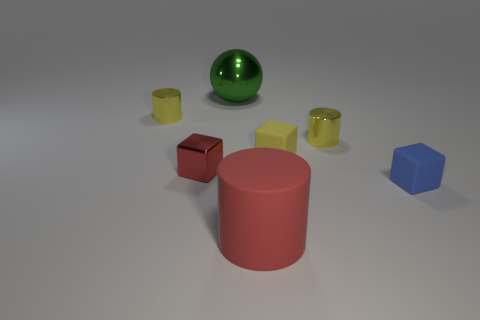What number of objects are either balls or large blue rubber cylinders?
Keep it short and to the point. 1. What is the size of the block that is the same color as the big rubber cylinder?
Your response must be concise. Small. There is a red rubber cylinder; are there any tiny red metal blocks on the left side of it?
Provide a succinct answer. Yes. Is the number of yellow things that are to the left of the green ball greater than the number of small shiny cubes in front of the tiny blue object?
Make the answer very short. Yes. What number of cubes are red objects or green metal things?
Keep it short and to the point. 1. What is the material of the big cylinder that is the same color as the tiny shiny block?
Your answer should be compact. Rubber. Are there fewer tiny shiny blocks that are on the left side of the tiny metallic cube than green metallic balls on the left side of the small yellow block?
Your answer should be compact. Yes. How many objects are either things right of the tiny metal cube or tiny red objects?
Keep it short and to the point. 6. What is the shape of the tiny yellow metallic object that is behind the small cylinder that is to the right of the matte cylinder?
Provide a short and direct response. Cylinder. Is there a rubber object that has the same size as the green shiny sphere?
Ensure brevity in your answer.  Yes. 